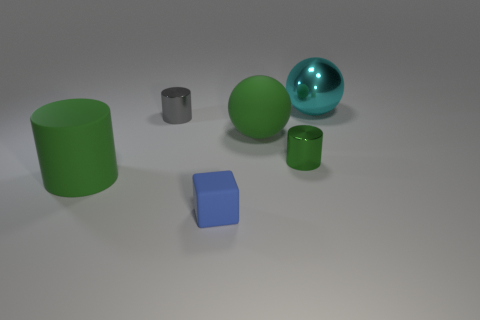Add 4 tiny rubber objects. How many objects exist? 10 Subtract all gray cylinders. How many cylinders are left? 2 Subtract all tiny gray cylinders. How many cylinders are left? 2 Subtract all cubes. How many objects are left? 5 Subtract all big yellow rubber cylinders. Subtract all matte things. How many objects are left? 3 Add 6 small matte objects. How many small matte objects are left? 7 Add 6 cylinders. How many cylinders exist? 9 Subtract 0 brown cylinders. How many objects are left? 6 Subtract all cyan blocks. Subtract all purple cylinders. How many blocks are left? 1 Subtract all cyan spheres. How many gray cylinders are left? 1 